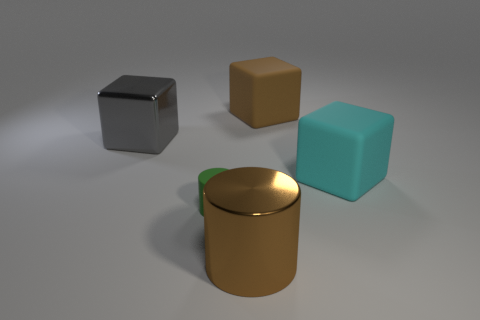There is a large rubber thing that is in front of the brown rubber thing; what is its shape?
Your answer should be compact. Cube. Are there more matte cubes than big blocks?
Ensure brevity in your answer.  No. There is a big rubber block left of the large cyan cube; is its color the same as the big cylinder?
Provide a succinct answer. Yes. How many objects are objects right of the matte cylinder or big rubber blocks behind the big cyan cube?
Ensure brevity in your answer.  3. How many large metal things are right of the rubber cylinder and behind the large brown metallic object?
Offer a terse response. 0. Does the large cyan block have the same material as the gray object?
Keep it short and to the point. No. What is the shape of the big brown thing to the right of the large metal thing that is in front of the large rubber thing in front of the gray metal object?
Make the answer very short. Cube. There is a big thing that is behind the brown shiny object and on the left side of the brown matte block; what is it made of?
Your answer should be compact. Metal. What color is the thing in front of the tiny green thing in front of the large brown rubber block on the right side of the green object?
Your answer should be very brief. Brown. How many brown things are either tiny spheres or big objects?
Give a very brief answer. 2. 